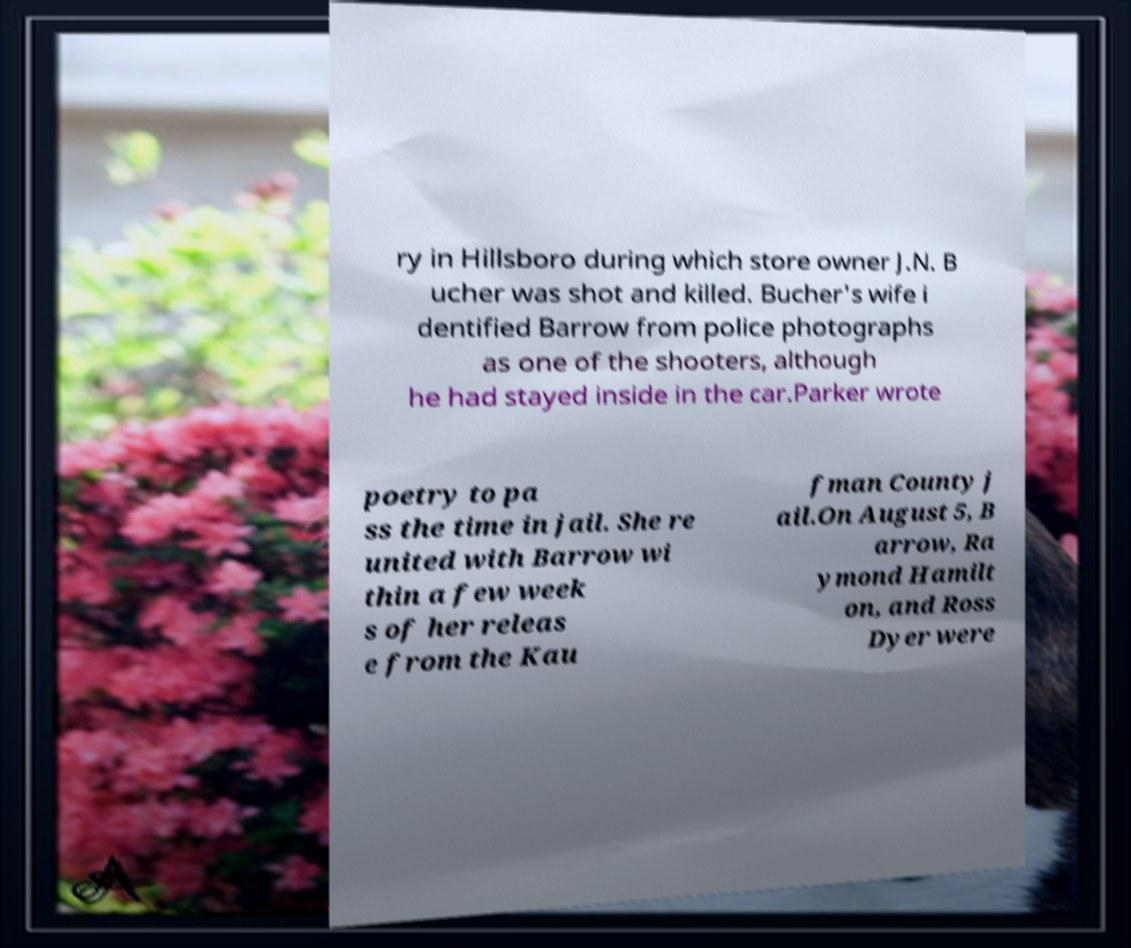Could you extract and type out the text from this image? ry in Hillsboro during which store owner J.N. B ucher was shot and killed. Bucher's wife i dentified Barrow from police photographs as one of the shooters, although he had stayed inside in the car.Parker wrote poetry to pa ss the time in jail. She re united with Barrow wi thin a few week s of her releas e from the Kau fman County j ail.On August 5, B arrow, Ra ymond Hamilt on, and Ross Dyer were 